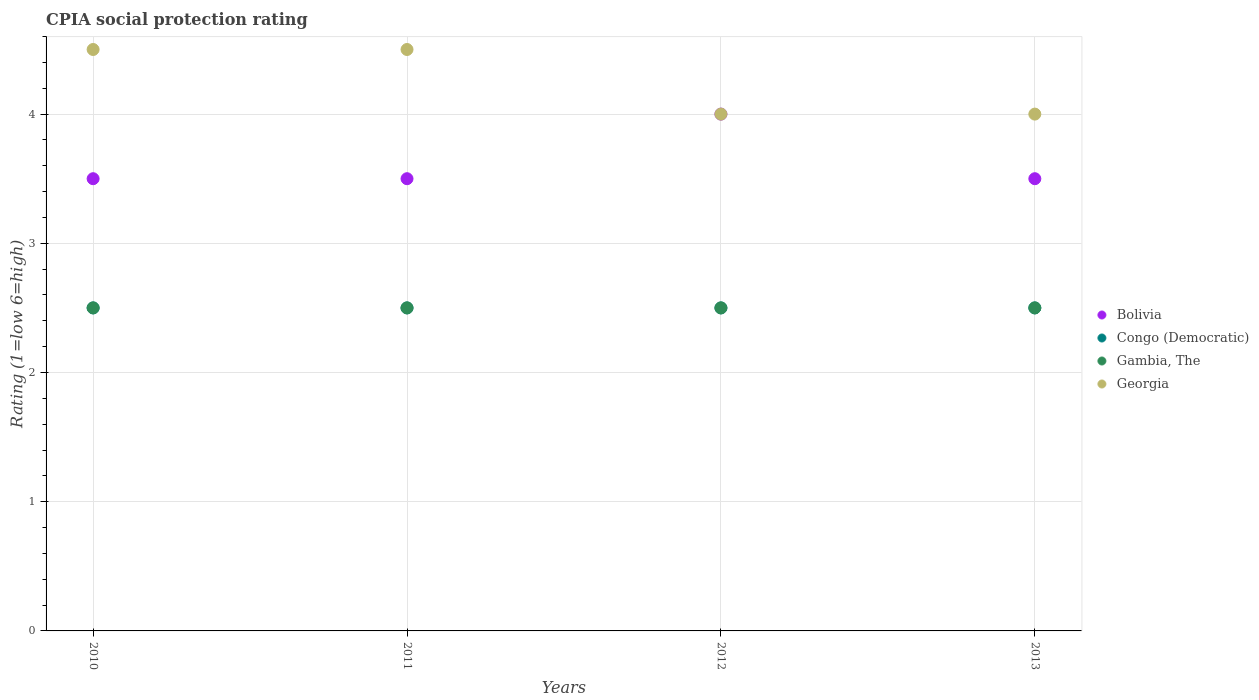Is the number of dotlines equal to the number of legend labels?
Your answer should be very brief. Yes. Across all years, what is the minimum CPIA rating in Georgia?
Ensure brevity in your answer.  4. In which year was the CPIA rating in Congo (Democratic) maximum?
Your answer should be compact. 2010. What is the total CPIA rating in Congo (Democratic) in the graph?
Keep it short and to the point. 10. What is the average CPIA rating in Bolivia per year?
Your response must be concise. 3.62. What is the difference between the highest and the second highest CPIA rating in Congo (Democratic)?
Offer a terse response. 0. What is the difference between the highest and the lowest CPIA rating in Georgia?
Make the answer very short. 0.5. Is it the case that in every year, the sum of the CPIA rating in Gambia, The and CPIA rating in Bolivia  is greater than the sum of CPIA rating in Georgia and CPIA rating in Congo (Democratic)?
Provide a succinct answer. No. Does the CPIA rating in Bolivia monotonically increase over the years?
Your answer should be compact. No. Is the CPIA rating in Bolivia strictly greater than the CPIA rating in Gambia, The over the years?
Offer a terse response. Yes. Is the CPIA rating in Gambia, The strictly less than the CPIA rating in Congo (Democratic) over the years?
Give a very brief answer. No. How many dotlines are there?
Your response must be concise. 4. Are the values on the major ticks of Y-axis written in scientific E-notation?
Offer a very short reply. No. How many legend labels are there?
Provide a short and direct response. 4. What is the title of the graph?
Make the answer very short. CPIA social protection rating. Does "Serbia" appear as one of the legend labels in the graph?
Provide a succinct answer. No. What is the label or title of the X-axis?
Your answer should be compact. Years. What is the Rating (1=low 6=high) in Congo (Democratic) in 2010?
Offer a very short reply. 2.5. What is the Rating (1=low 6=high) in Bolivia in 2011?
Your answer should be very brief. 3.5. What is the Rating (1=low 6=high) in Bolivia in 2013?
Keep it short and to the point. 3.5. What is the Rating (1=low 6=high) in Congo (Democratic) in 2013?
Make the answer very short. 2.5. What is the Rating (1=low 6=high) in Gambia, The in 2013?
Offer a terse response. 2.5. What is the Rating (1=low 6=high) in Georgia in 2013?
Provide a short and direct response. 4. Across all years, what is the maximum Rating (1=low 6=high) of Bolivia?
Give a very brief answer. 4. Across all years, what is the maximum Rating (1=low 6=high) in Gambia, The?
Provide a succinct answer. 2.5. Across all years, what is the minimum Rating (1=low 6=high) in Congo (Democratic)?
Provide a succinct answer. 2.5. Across all years, what is the minimum Rating (1=low 6=high) in Gambia, The?
Give a very brief answer. 2.5. What is the total Rating (1=low 6=high) in Bolivia in the graph?
Ensure brevity in your answer.  14.5. What is the total Rating (1=low 6=high) of Gambia, The in the graph?
Your answer should be very brief. 10. What is the total Rating (1=low 6=high) in Georgia in the graph?
Your answer should be compact. 17. What is the difference between the Rating (1=low 6=high) in Bolivia in 2010 and that in 2011?
Keep it short and to the point. 0. What is the difference between the Rating (1=low 6=high) in Congo (Democratic) in 2010 and that in 2011?
Provide a succinct answer. 0. What is the difference between the Rating (1=low 6=high) of Georgia in 2010 and that in 2011?
Ensure brevity in your answer.  0. What is the difference between the Rating (1=low 6=high) in Congo (Democratic) in 2010 and that in 2012?
Your response must be concise. 0. What is the difference between the Rating (1=low 6=high) in Gambia, The in 2010 and that in 2012?
Ensure brevity in your answer.  0. What is the difference between the Rating (1=low 6=high) in Georgia in 2010 and that in 2012?
Keep it short and to the point. 0.5. What is the difference between the Rating (1=low 6=high) of Gambia, The in 2010 and that in 2013?
Provide a short and direct response. 0. What is the difference between the Rating (1=low 6=high) in Congo (Democratic) in 2011 and that in 2012?
Give a very brief answer. 0. What is the difference between the Rating (1=low 6=high) in Georgia in 2011 and that in 2012?
Keep it short and to the point. 0.5. What is the difference between the Rating (1=low 6=high) in Congo (Democratic) in 2011 and that in 2013?
Your response must be concise. 0. What is the difference between the Rating (1=low 6=high) in Gambia, The in 2011 and that in 2013?
Make the answer very short. 0. What is the difference between the Rating (1=low 6=high) in Georgia in 2011 and that in 2013?
Offer a very short reply. 0.5. What is the difference between the Rating (1=low 6=high) in Congo (Democratic) in 2012 and that in 2013?
Your answer should be very brief. 0. What is the difference between the Rating (1=low 6=high) in Georgia in 2012 and that in 2013?
Offer a terse response. 0. What is the difference between the Rating (1=low 6=high) of Bolivia in 2010 and the Rating (1=low 6=high) of Georgia in 2011?
Your answer should be compact. -1. What is the difference between the Rating (1=low 6=high) of Congo (Democratic) in 2010 and the Rating (1=low 6=high) of Gambia, The in 2011?
Your answer should be compact. 0. What is the difference between the Rating (1=low 6=high) of Congo (Democratic) in 2010 and the Rating (1=low 6=high) of Georgia in 2011?
Keep it short and to the point. -2. What is the difference between the Rating (1=low 6=high) in Gambia, The in 2010 and the Rating (1=low 6=high) in Georgia in 2011?
Offer a terse response. -2. What is the difference between the Rating (1=low 6=high) in Bolivia in 2010 and the Rating (1=low 6=high) in Congo (Democratic) in 2012?
Provide a short and direct response. 1. What is the difference between the Rating (1=low 6=high) in Bolivia in 2010 and the Rating (1=low 6=high) in Georgia in 2012?
Provide a short and direct response. -0.5. What is the difference between the Rating (1=low 6=high) in Congo (Democratic) in 2010 and the Rating (1=low 6=high) in Gambia, The in 2012?
Your response must be concise. 0. What is the difference between the Rating (1=low 6=high) in Bolivia in 2010 and the Rating (1=low 6=high) in Georgia in 2013?
Provide a succinct answer. -0.5. What is the difference between the Rating (1=low 6=high) in Congo (Democratic) in 2010 and the Rating (1=low 6=high) in Georgia in 2013?
Your response must be concise. -1.5. What is the difference between the Rating (1=low 6=high) in Bolivia in 2011 and the Rating (1=low 6=high) in Congo (Democratic) in 2012?
Your response must be concise. 1. What is the difference between the Rating (1=low 6=high) of Bolivia in 2011 and the Rating (1=low 6=high) of Gambia, The in 2012?
Your response must be concise. 1. What is the difference between the Rating (1=low 6=high) of Bolivia in 2011 and the Rating (1=low 6=high) of Georgia in 2012?
Make the answer very short. -0.5. What is the difference between the Rating (1=low 6=high) in Bolivia in 2011 and the Rating (1=low 6=high) in Congo (Democratic) in 2013?
Make the answer very short. 1. What is the difference between the Rating (1=low 6=high) in Bolivia in 2011 and the Rating (1=low 6=high) in Gambia, The in 2013?
Offer a terse response. 1. What is the difference between the Rating (1=low 6=high) in Bolivia in 2011 and the Rating (1=low 6=high) in Georgia in 2013?
Provide a succinct answer. -0.5. What is the difference between the Rating (1=low 6=high) of Congo (Democratic) in 2011 and the Rating (1=low 6=high) of Gambia, The in 2013?
Provide a short and direct response. 0. What is the difference between the Rating (1=low 6=high) of Bolivia in 2012 and the Rating (1=low 6=high) of Gambia, The in 2013?
Offer a terse response. 1.5. What is the difference between the Rating (1=low 6=high) of Bolivia in 2012 and the Rating (1=low 6=high) of Georgia in 2013?
Make the answer very short. 0. What is the difference between the Rating (1=low 6=high) in Congo (Democratic) in 2012 and the Rating (1=low 6=high) in Gambia, The in 2013?
Keep it short and to the point. 0. What is the average Rating (1=low 6=high) of Bolivia per year?
Give a very brief answer. 3.62. What is the average Rating (1=low 6=high) of Gambia, The per year?
Ensure brevity in your answer.  2.5. What is the average Rating (1=low 6=high) in Georgia per year?
Give a very brief answer. 4.25. In the year 2010, what is the difference between the Rating (1=low 6=high) in Bolivia and Rating (1=low 6=high) in Gambia, The?
Keep it short and to the point. 1. In the year 2010, what is the difference between the Rating (1=low 6=high) in Bolivia and Rating (1=low 6=high) in Georgia?
Provide a succinct answer. -1. In the year 2010, what is the difference between the Rating (1=low 6=high) of Congo (Democratic) and Rating (1=low 6=high) of Georgia?
Offer a terse response. -2. In the year 2011, what is the difference between the Rating (1=low 6=high) of Bolivia and Rating (1=low 6=high) of Congo (Democratic)?
Offer a very short reply. 1. In the year 2011, what is the difference between the Rating (1=low 6=high) of Bolivia and Rating (1=low 6=high) of Gambia, The?
Make the answer very short. 1. In the year 2011, what is the difference between the Rating (1=low 6=high) in Bolivia and Rating (1=low 6=high) in Georgia?
Provide a succinct answer. -1. In the year 2011, what is the difference between the Rating (1=low 6=high) in Gambia, The and Rating (1=low 6=high) in Georgia?
Provide a succinct answer. -2. In the year 2012, what is the difference between the Rating (1=low 6=high) in Bolivia and Rating (1=low 6=high) in Gambia, The?
Provide a succinct answer. 1.5. In the year 2012, what is the difference between the Rating (1=low 6=high) of Gambia, The and Rating (1=low 6=high) of Georgia?
Ensure brevity in your answer.  -1.5. In the year 2013, what is the difference between the Rating (1=low 6=high) in Bolivia and Rating (1=low 6=high) in Gambia, The?
Make the answer very short. 1. In the year 2013, what is the difference between the Rating (1=low 6=high) of Congo (Democratic) and Rating (1=low 6=high) of Gambia, The?
Provide a succinct answer. 0. In the year 2013, what is the difference between the Rating (1=low 6=high) in Congo (Democratic) and Rating (1=low 6=high) in Georgia?
Provide a short and direct response. -1.5. What is the ratio of the Rating (1=low 6=high) of Bolivia in 2010 to that in 2011?
Ensure brevity in your answer.  1. What is the ratio of the Rating (1=low 6=high) in Congo (Democratic) in 2010 to that in 2011?
Provide a succinct answer. 1. What is the ratio of the Rating (1=low 6=high) of Georgia in 2010 to that in 2011?
Make the answer very short. 1. What is the ratio of the Rating (1=low 6=high) in Congo (Democratic) in 2010 to that in 2012?
Give a very brief answer. 1. What is the ratio of the Rating (1=low 6=high) of Georgia in 2010 to that in 2012?
Make the answer very short. 1.12. What is the ratio of the Rating (1=low 6=high) of Bolivia in 2010 to that in 2013?
Offer a very short reply. 1. What is the ratio of the Rating (1=low 6=high) in Congo (Democratic) in 2010 to that in 2013?
Offer a terse response. 1. What is the ratio of the Rating (1=low 6=high) in Gambia, The in 2010 to that in 2013?
Offer a terse response. 1. What is the ratio of the Rating (1=low 6=high) in Bolivia in 2011 to that in 2012?
Your answer should be very brief. 0.88. What is the ratio of the Rating (1=low 6=high) of Congo (Democratic) in 2011 to that in 2012?
Make the answer very short. 1. What is the ratio of the Rating (1=low 6=high) in Georgia in 2011 to that in 2012?
Your answer should be compact. 1.12. What is the ratio of the Rating (1=low 6=high) in Bolivia in 2011 to that in 2013?
Offer a very short reply. 1. What is the ratio of the Rating (1=low 6=high) in Congo (Democratic) in 2011 to that in 2013?
Your response must be concise. 1. What is the ratio of the Rating (1=low 6=high) of Georgia in 2011 to that in 2013?
Offer a very short reply. 1.12. What is the ratio of the Rating (1=low 6=high) of Bolivia in 2012 to that in 2013?
Your answer should be compact. 1.14. What is the ratio of the Rating (1=low 6=high) in Georgia in 2012 to that in 2013?
Your response must be concise. 1. What is the difference between the highest and the second highest Rating (1=low 6=high) of Congo (Democratic)?
Your response must be concise. 0. What is the difference between the highest and the second highest Rating (1=low 6=high) in Gambia, The?
Your answer should be compact. 0. What is the difference between the highest and the lowest Rating (1=low 6=high) in Bolivia?
Ensure brevity in your answer.  0.5. What is the difference between the highest and the lowest Rating (1=low 6=high) of Congo (Democratic)?
Ensure brevity in your answer.  0. What is the difference between the highest and the lowest Rating (1=low 6=high) in Georgia?
Keep it short and to the point. 0.5. 